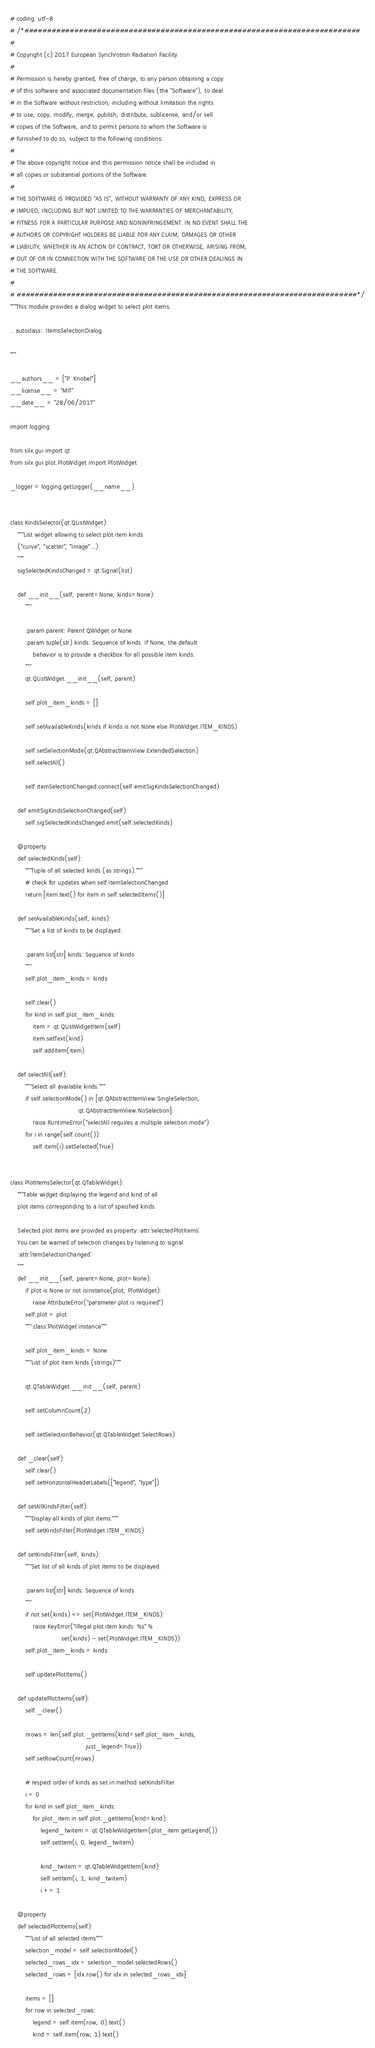<code> <loc_0><loc_0><loc_500><loc_500><_Python_># coding: utf-8
# /*##########################################################################
#
# Copyright (c) 2017 European Synchrotron Radiation Facility
#
# Permission is hereby granted, free of charge, to any person obtaining a copy
# of this software and associated documentation files (the "Software"), to deal
# in the Software without restriction, including without limitation the rights
# to use, copy, modify, merge, publish, distribute, sublicense, and/or sell
# copies of the Software, and to permit persons to whom the Software is
# furnished to do so, subject to the following conditions:
#
# The above copyright notice and this permission notice shall be included in
# all copies or substantial portions of the Software.
#
# THE SOFTWARE IS PROVIDED "AS IS", WITHOUT WARRANTY OF ANY KIND, EXPRESS OR
# IMPLIED, INCLUDING BUT NOT LIMITED TO THE WARRANTIES OF MERCHANTABILITY,
# FITNESS FOR A PARTICULAR PURPOSE AND NONINFRINGEMENT. IN NO EVENT SHALL THE
# AUTHORS OR COPYRIGHT HOLDERS BE LIABLE FOR ANY CLAIM, DAMAGES OR OTHER
# LIABILITY, WHETHER IN AN ACTION OF CONTRACT, TORT OR OTHERWISE, ARISING FROM,
# OUT OF OR IN CONNECTION WITH THE SOFTWARE OR THE USE OR OTHER DEALINGS IN
# THE SOFTWARE.
#
# ###########################################################################*/
"""This module provides a dialog widget to select plot items.

.. autoclass:: ItemsSelectionDialog

"""

__authors__ = ["P. Knobel"]
__license__ = "MIT"
__date__ = "28/06/2017"

import logging

from silx.gui import qt
from silx.gui.plot.PlotWidget import PlotWidget

_logger = logging.getLogger(__name__)


class KindsSelector(qt.QListWidget):
    """List widget allowing to select plot item kinds
    ("curve", "scatter", "image"...)
    """
    sigSelectedKindsChanged = qt.Signal(list)

    def __init__(self, parent=None, kinds=None):
        """

        :param parent: Parent QWidget or None
        :param tuple(str) kinds: Sequence of kinds. If None, the default
            behavior is to provide a checkbox for all possible item kinds.
        """
        qt.QListWidget.__init__(self, parent)

        self.plot_item_kinds = []

        self.setAvailableKinds(kinds if kinds is not None else PlotWidget.ITEM_KINDS)

        self.setSelectionMode(qt.QAbstractItemView.ExtendedSelection)
        self.selectAll()

        self.itemSelectionChanged.connect(self.emitSigKindsSelectionChanged)

    def emitSigKindsSelectionChanged(self):
        self.sigSelectedKindsChanged.emit(self.selectedKinds)

    @property
    def selectedKinds(self):
        """Tuple of all selected kinds (as strings)."""
        # check for updates when self.itemSelectionChanged
        return [item.text() for item in self.selectedItems()]

    def setAvailableKinds(self, kinds):
        """Set a list of kinds to be displayed.

        :param list[str] kinds: Sequence of kinds
        """
        self.plot_item_kinds = kinds

        self.clear()
        for kind in self.plot_item_kinds:
            item = qt.QListWidgetItem(self)
            item.setText(kind)
            self.addItem(item)

    def selectAll(self):
        """Select all available kinds."""
        if self.selectionMode() in [qt.QAbstractItemView.SingleSelection,
                                    qt.QAbstractItemView.NoSelection]:
            raise RuntimeError("selectAll requires a multiple selection mode")
        for i in range(self.count()):
            self.item(i).setSelected(True)


class PlotItemsSelector(qt.QTableWidget):
    """Table widget displaying the legend and kind of all
    plot items corresponding to a list of specified kinds.

    Selected plot items are provided as property :attr:`selectedPlotItems`.
    You can be warned of selection changes by listening to signal
    :attr:`itemSelectionChanged`.
    """
    def __init__(self, parent=None, plot=None):
        if plot is None or not isinstance(plot, PlotWidget):
            raise AttributeError("parameter plot is required")
        self.plot = plot
        """:class:`PlotWidget` instance"""

        self.plot_item_kinds = None
        """List of plot item kinds (strings)"""

        qt.QTableWidget.__init__(self, parent)

        self.setColumnCount(2)

        self.setSelectionBehavior(qt.QTableWidget.SelectRows)

    def _clear(self):
        self.clear()
        self.setHorizontalHeaderLabels(["legend", "type"])

    def setAllKindsFilter(self):
        """Display all kinds of plot items."""
        self.setKindsFilter(PlotWidget.ITEM_KINDS)

    def setKindsFilter(self, kinds):
        """Set list of all kinds of plot items to be displayed.

        :param list[str] kinds: Sequence of kinds
        """
        if not set(kinds) <= set(PlotWidget.ITEM_KINDS):
            raise KeyError("Illegal plot item kinds: %s" %
                           set(kinds) - set(PlotWidget.ITEM_KINDS))
        self.plot_item_kinds = kinds

        self.updatePlotItems()

    def updatePlotItems(self):
        self._clear()

        nrows = len(self.plot._getItems(kind=self.plot_item_kinds,
                                        just_legend=True))
        self.setRowCount(nrows)

        # respect order of kinds as set in method setKindsFilter
        i = 0
        for kind in self.plot_item_kinds:
            for plot_item in self.plot._getItems(kind=kind):
                legend_twitem = qt.QTableWidgetItem(plot_item.getLegend())
                self.setItem(i, 0, legend_twitem)

                kind_twitem = qt.QTableWidgetItem(kind)
                self.setItem(i, 1, kind_twitem)
                i += 1

    @property
    def selectedPlotItems(self):
        """List of all selected items"""
        selection_model = self.selectionModel()
        selected_rows_idx = selection_model.selectedRows()
        selected_rows = [idx.row() for idx in selected_rows_idx]

        items = []
        for row in selected_rows:
            legend = self.item(row, 0).text()
            kind = self.item(row, 1).text()</code> 